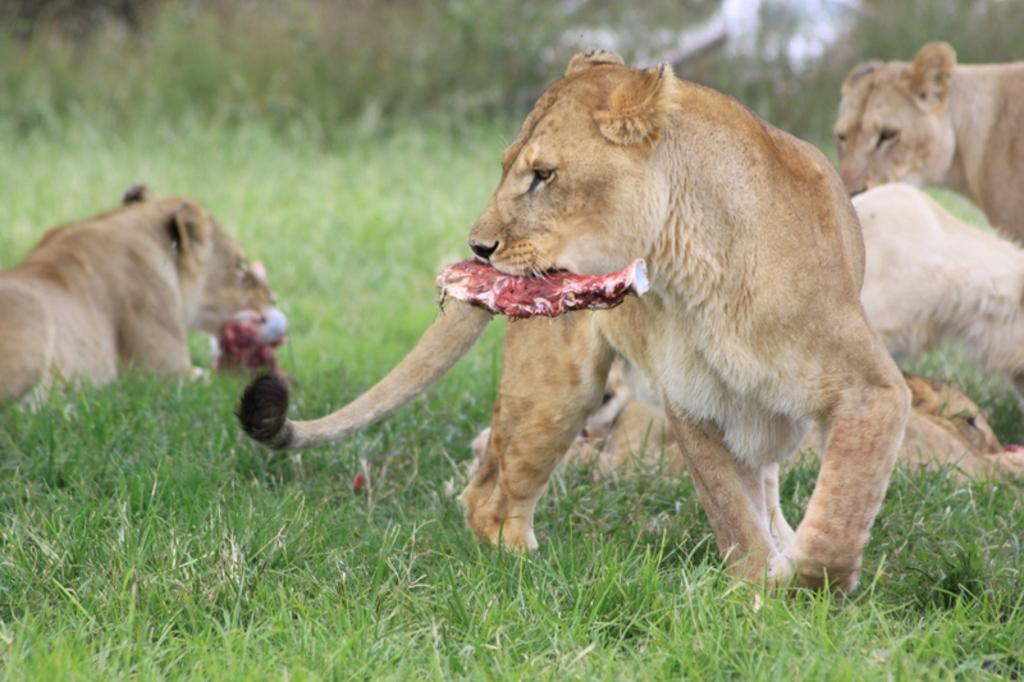What animals are present in the image? The image features lions. How many lions are in the image? There are two lions in the image. What are the lions doing in the image? The lions are eating meat. What type of vegetation can be seen in the image? There is grass visible in the image. What type of holiday is being celebrated by the goose in the image? There is no goose present in the image, and therefore no holiday can be associated with it. 